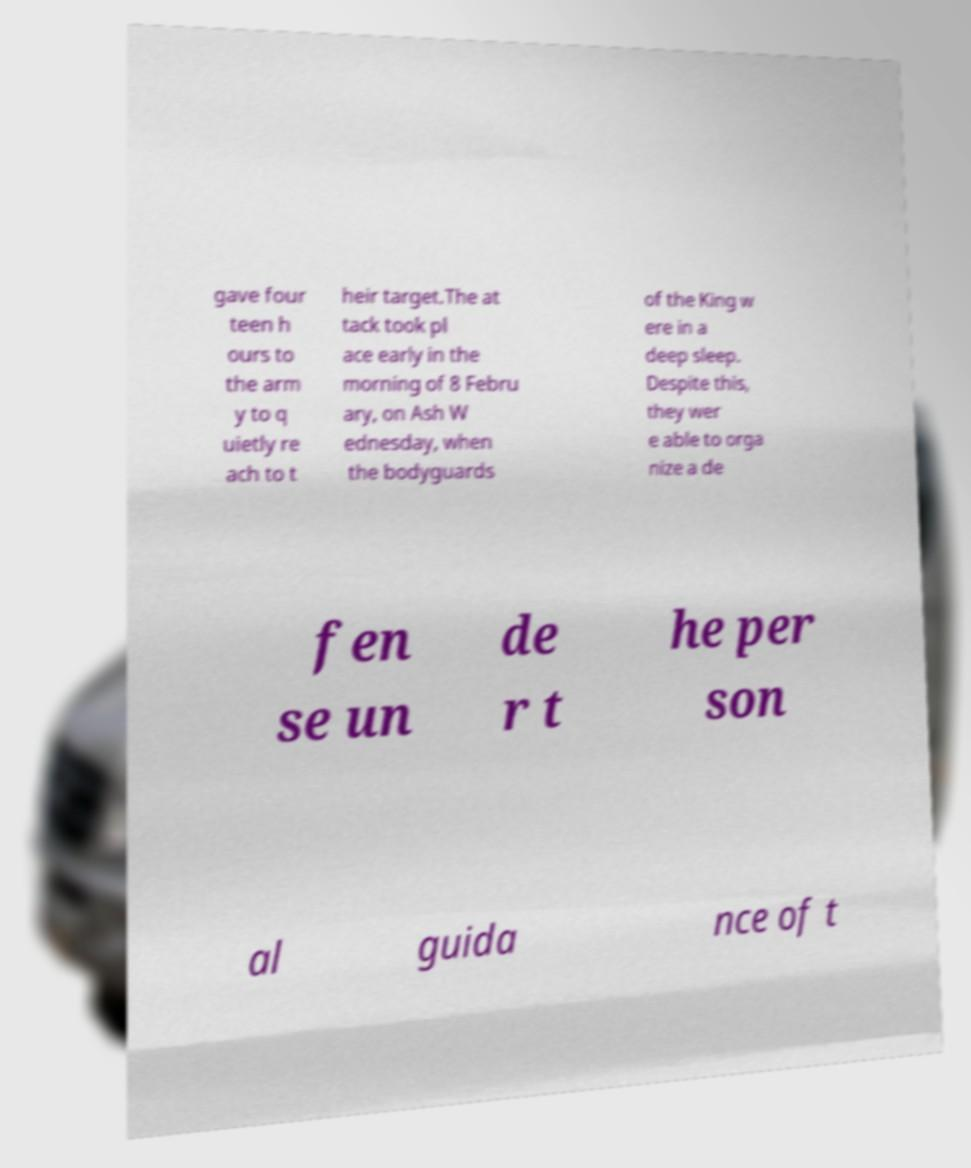Please read and relay the text visible in this image. What does it say? gave four teen h ours to the arm y to q uietly re ach to t heir target.The at tack took pl ace early in the morning of 8 Febru ary, on Ash W ednesday, when the bodyguards of the King w ere in a deep sleep. Despite this, they wer e able to orga nize a de fen se un de r t he per son al guida nce of t 